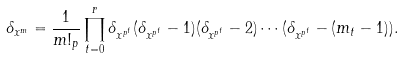<formula> <loc_0><loc_0><loc_500><loc_500>\delta _ { x ^ { m } } = \frac { 1 } { m ! _ { p } } \prod _ { t = 0 } ^ { r } \delta _ { x ^ { p ^ { t } } } ( \delta _ { x ^ { p ^ { t } } } - 1 ) ( \delta _ { x ^ { p ^ { t } } } - 2 ) \cdots ( \delta _ { x ^ { p ^ { t } } } - ( m _ { t } - 1 ) ) .</formula> 